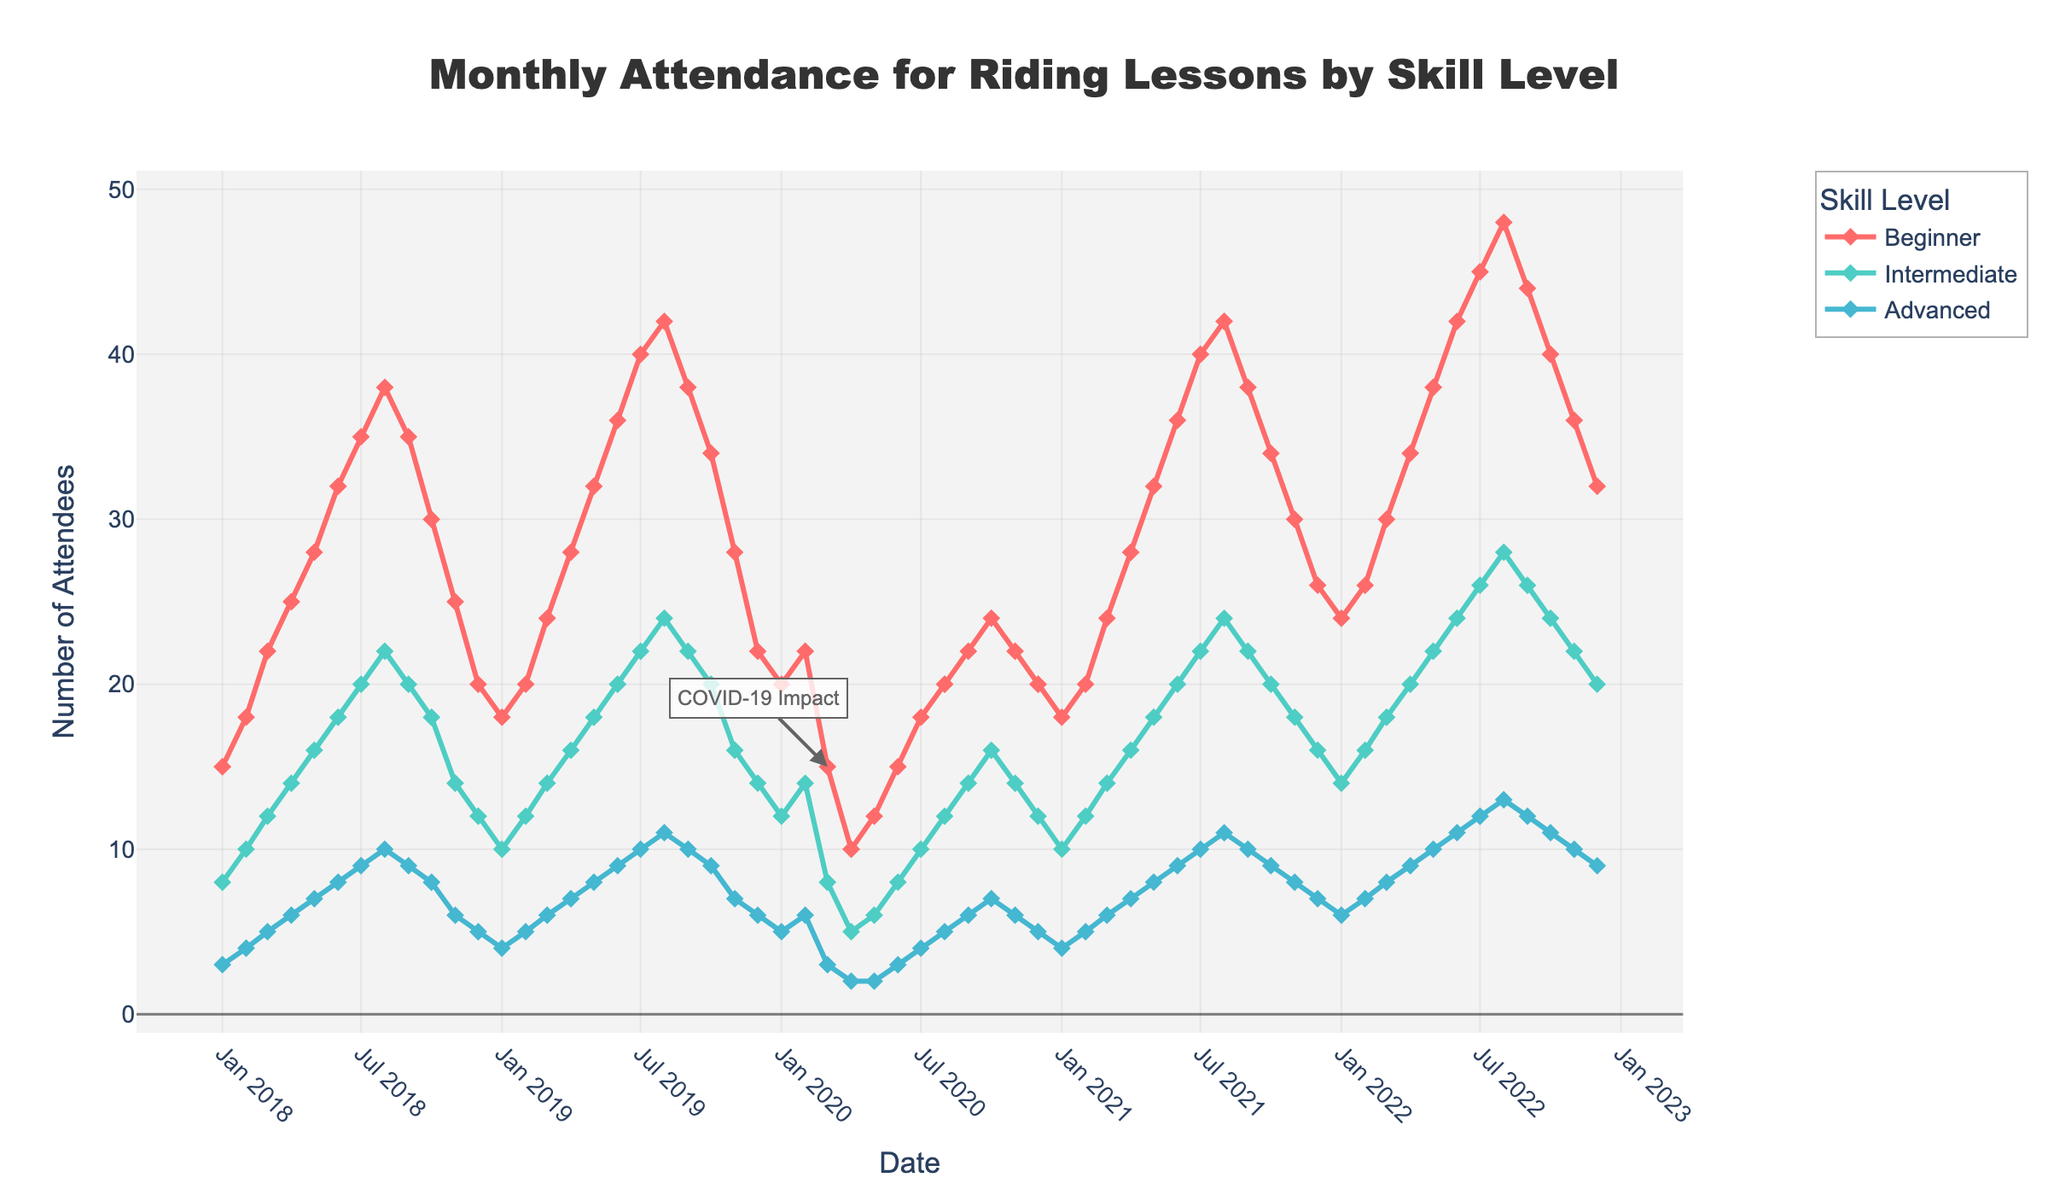What month and year saw the highest attendance for Beginner skill level? Look for the peak in the 'Beginner' line on the chart. It occurs at the highest point, which is in July 2022.
Answer: July 2022 When did the 'Advanced' skill level see the lowest attendance, and what was the number? Identify the lowest point in the 'Advanced' line. This occurs in April and May 2020 with a value of 2.
Answer: April 2020 and May 2020, 2 attendees Compare Beginner and Intermediate attendance in March 2021. Which is higher and by how much? Locate the points for March 2021 for both 'Beginner' and 'Intermediate' and compare their values. Beginner attendance is 24, Intermediate attendance is 14, so the difference is 10.
Answer: Beginner is higher by 10 What is the trend noticed for Beginner attendance post-March 2020 (COVID-19 impact annotation)? Observing the line for 'Beginner' post-March 2020 shows that the attendance dropped significantly but then began to gradually rise again.
Answer: Decrease followed by gradual increase Summarize the overall trend for Intermediate attendance over the five years. Examine the 'Intermediate' line over the entire period. It shows a general upward trend with minor fluctuations, peaking in July 2022.
Answer: General upward trend with fluctuations In which year and month was there an equal number of attendees for Beginner and Intermediate skill levels, and what was the number? Identify the points where the 'Beginner' and 'Intermediate' lines intersect. This occurs in March 2020, with both at 15 attendees.
Answer: March 2020, 15 attendees How did the attendees for the Advanced skill level change from February to March 2020? Check the numbers for Advanced level in February (6) and March (3) 2020 and calculate the difference.
Answer: Decreased by 3 Which month consistently shows a decline in Beginner attendance across the years observed? Identify the lowest points in the 'Beginner' line for each year and check if there's a pattern. December consistently shows a decline.
Answer: December Calculate the average monthly attendance for Intermediate skill level in 2019. Sum the monthly attendance numbers for Intermediate in 2019 and divide by 12. Values are: 10, 12, 14, 16, 18, 20, 22, 24, 22, 20, 16, 14. Total = 208, Average = 208/12 = 17.33
Answer: 17.33 By how much did Beginner attendance increase from January 2018 to January 2019? Beginner attendance in January 2018 was 15 and in January 2019 was 18. Calculate the difference (18 - 15).
Answer: Increased by 3 